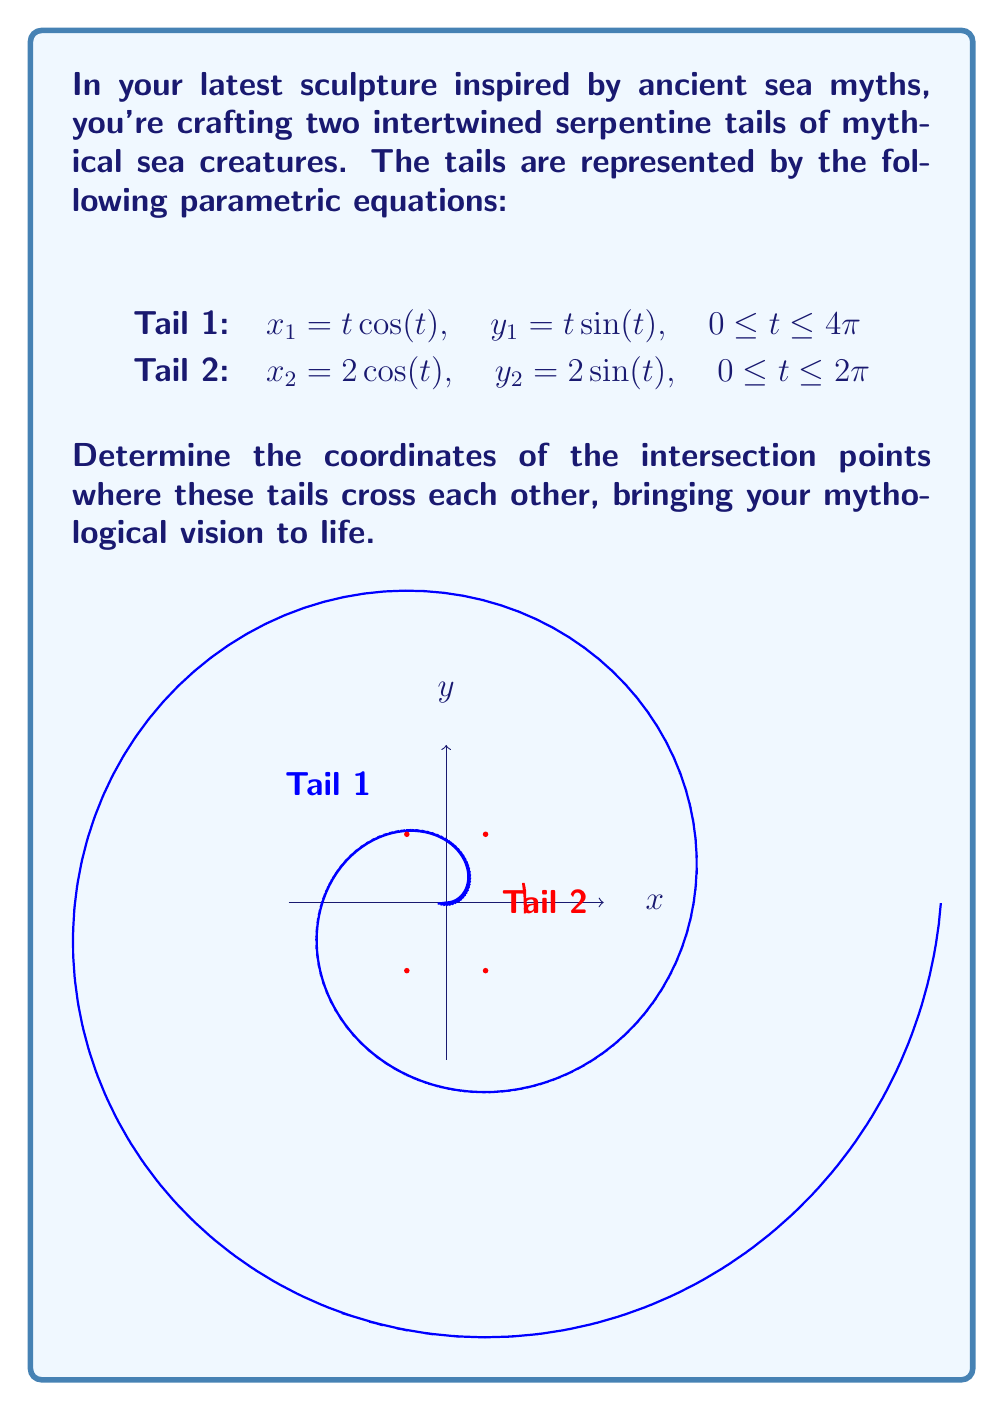Could you help me with this problem? To find the intersection points, we need to solve the system of equations:

$$\begin{cases}
t\cos(t) = 2\cos(s) \\
t\sin(t) = 2\sin(s)
\end{cases}$$

Where $t$ and $s$ are the parameters for Tail 1 and Tail 2 respectively.

Step 1: Square and add the equations
$$(t\cos(t))^2 + (t\sin(t))^2 = 4\cos^2(s) + 4\sin^2(s)$$

Step 2: Simplify using trigonometric identities
$$t^2(\cos^2(t) + \sin^2(t)) = 4(\cos^2(s) + \sin^2(s))$$
$$t^2 = 4$$

Step 3: Solve for t
$$t = \pm 2$$

Step 4: Substitute $t = 2$ into the original equations
$$2\cos(2) = 2\cos(s)$$
$$2\sin(2) = 2\sin(s)$$

This gives us two solutions:
$$s_1 = 2 \text{ and } s_2 = 2\pi - 2$$

Step 5: Calculate the coordinates
For $t = 2$:
$x = 2\cos(2) \approx -0.8322$
$y = 2\sin(2) \approx 1.8186$

For $t = -2$:
$x = -2\cos(2) \approx 0.8322$
$y = -2\sin(2) \approx -1.8186$

Step 6: Verify these points satisfy both parametric equations

Therefore, the intersection points are approximately:
$(-0.8322, 1.8186)$ and $(0.8322, -1.8186)$
Answer: $(-0.8322, 1.8186)$ and $(0.8322, -1.8186)$ 